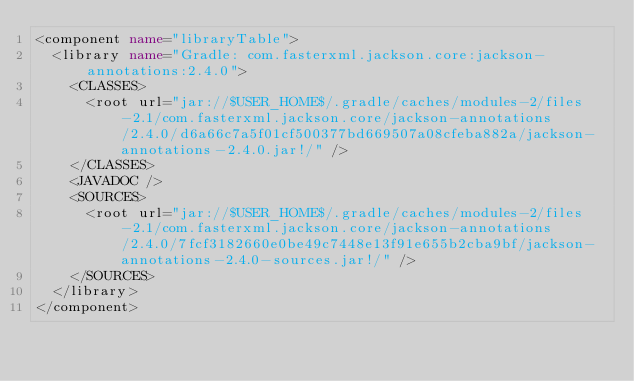<code> <loc_0><loc_0><loc_500><loc_500><_XML_><component name="libraryTable">
  <library name="Gradle: com.fasterxml.jackson.core:jackson-annotations:2.4.0">
    <CLASSES>
      <root url="jar://$USER_HOME$/.gradle/caches/modules-2/files-2.1/com.fasterxml.jackson.core/jackson-annotations/2.4.0/d6a66c7a5f01cf500377bd669507a08cfeba882a/jackson-annotations-2.4.0.jar!/" />
    </CLASSES>
    <JAVADOC />
    <SOURCES>
      <root url="jar://$USER_HOME$/.gradle/caches/modules-2/files-2.1/com.fasterxml.jackson.core/jackson-annotations/2.4.0/7fcf3182660e0be49c7448e13f91e655b2cba9bf/jackson-annotations-2.4.0-sources.jar!/" />
    </SOURCES>
  </library>
</component></code> 